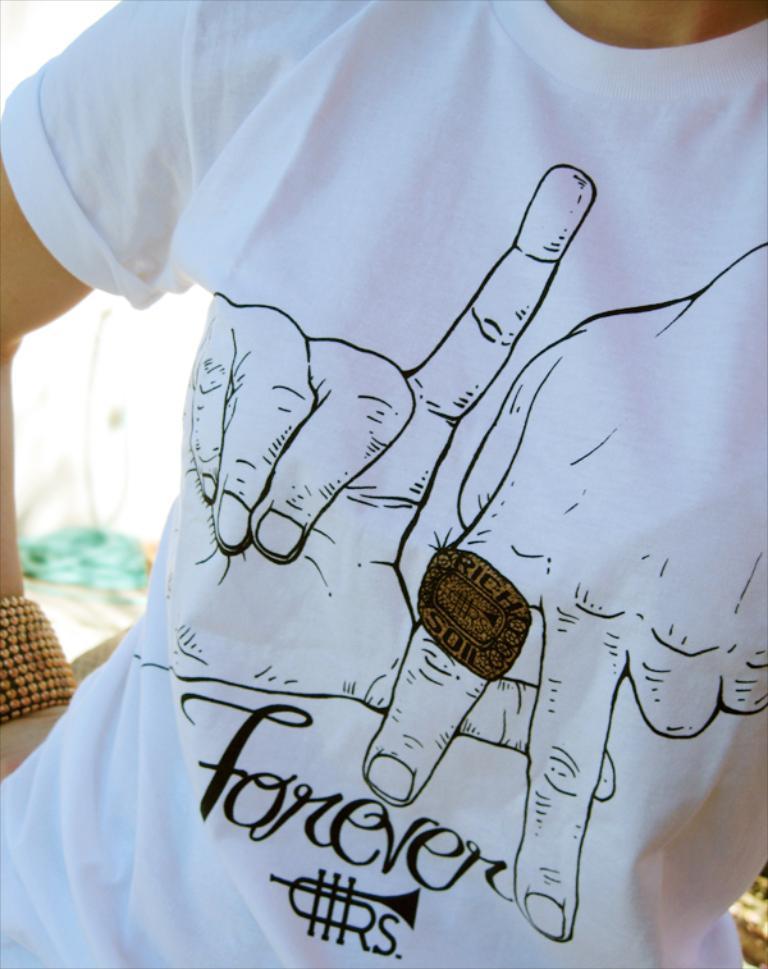Could you give a brief overview of what you see in this image? In this image we can see a person wearing a white shirt, there is some text and hands with a ring is printed on the shirt. 